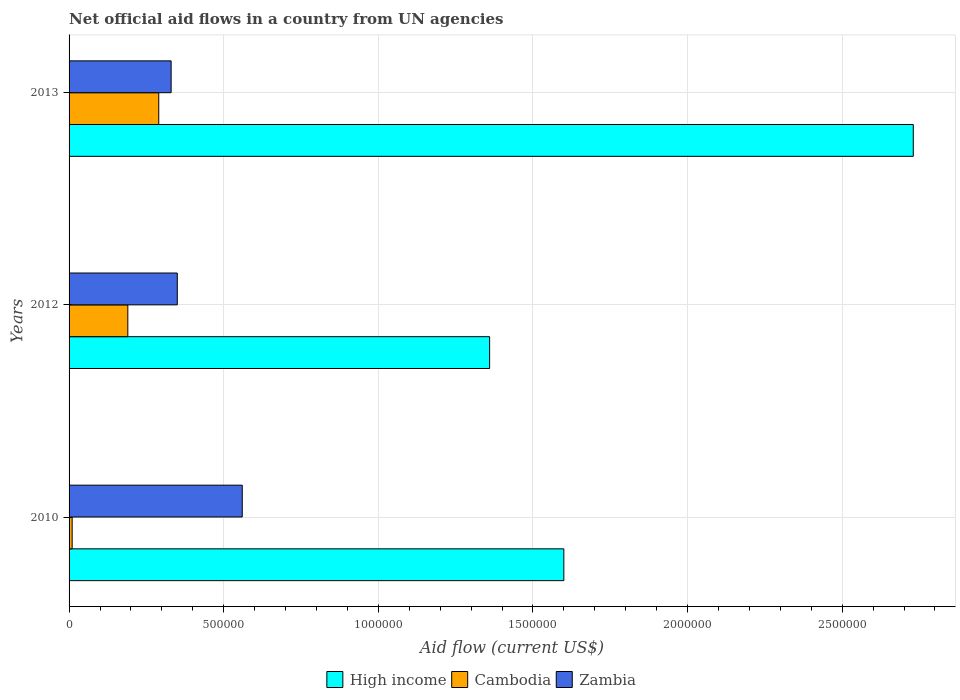How many different coloured bars are there?
Give a very brief answer. 3. How many groups of bars are there?
Offer a terse response. 3. Are the number of bars per tick equal to the number of legend labels?
Your answer should be compact. Yes. Are the number of bars on each tick of the Y-axis equal?
Provide a short and direct response. Yes. How many bars are there on the 1st tick from the top?
Make the answer very short. 3. What is the label of the 2nd group of bars from the top?
Ensure brevity in your answer.  2012. In how many cases, is the number of bars for a given year not equal to the number of legend labels?
Offer a terse response. 0. What is the net official aid flow in High income in 2010?
Your answer should be very brief. 1.60e+06. Across all years, what is the maximum net official aid flow in High income?
Ensure brevity in your answer.  2.73e+06. Across all years, what is the minimum net official aid flow in High income?
Provide a succinct answer. 1.36e+06. In which year was the net official aid flow in Zambia maximum?
Your response must be concise. 2010. What is the total net official aid flow in High income in the graph?
Provide a short and direct response. 5.69e+06. What is the difference between the net official aid flow in Cambodia in 2010 and that in 2013?
Keep it short and to the point. -2.80e+05. What is the difference between the net official aid flow in Cambodia in 2013 and the net official aid flow in High income in 2012?
Keep it short and to the point. -1.07e+06. What is the average net official aid flow in High income per year?
Your answer should be very brief. 1.90e+06. In how many years, is the net official aid flow in High income greater than 2300000 US$?
Your response must be concise. 1. What is the ratio of the net official aid flow in Cambodia in 2010 to that in 2013?
Give a very brief answer. 0.03. Is the net official aid flow in High income in 2012 less than that in 2013?
Ensure brevity in your answer.  Yes. Is the difference between the net official aid flow in Zambia in 2010 and 2013 greater than the difference between the net official aid flow in Cambodia in 2010 and 2013?
Give a very brief answer. Yes. What is the difference between the highest and the second highest net official aid flow in High income?
Keep it short and to the point. 1.13e+06. What is the difference between the highest and the lowest net official aid flow in Cambodia?
Offer a very short reply. 2.80e+05. In how many years, is the net official aid flow in Zambia greater than the average net official aid flow in Zambia taken over all years?
Give a very brief answer. 1. Is the sum of the net official aid flow in High income in 2010 and 2013 greater than the maximum net official aid flow in Cambodia across all years?
Ensure brevity in your answer.  Yes. What does the 2nd bar from the top in 2012 represents?
Your answer should be very brief. Cambodia. What does the 2nd bar from the bottom in 2010 represents?
Offer a very short reply. Cambodia. Is it the case that in every year, the sum of the net official aid flow in Zambia and net official aid flow in Cambodia is greater than the net official aid flow in High income?
Your response must be concise. No. How many years are there in the graph?
Make the answer very short. 3. Does the graph contain any zero values?
Your answer should be very brief. No. What is the title of the graph?
Your answer should be compact. Net official aid flows in a country from UN agencies. Does "Austria" appear as one of the legend labels in the graph?
Give a very brief answer. No. What is the label or title of the X-axis?
Ensure brevity in your answer.  Aid flow (current US$). What is the Aid flow (current US$) in High income in 2010?
Your answer should be very brief. 1.60e+06. What is the Aid flow (current US$) of Zambia in 2010?
Offer a very short reply. 5.60e+05. What is the Aid flow (current US$) of High income in 2012?
Offer a very short reply. 1.36e+06. What is the Aid flow (current US$) in Cambodia in 2012?
Your answer should be very brief. 1.90e+05. What is the Aid flow (current US$) of Zambia in 2012?
Keep it short and to the point. 3.50e+05. What is the Aid flow (current US$) in High income in 2013?
Your response must be concise. 2.73e+06. Across all years, what is the maximum Aid flow (current US$) of High income?
Provide a succinct answer. 2.73e+06. Across all years, what is the maximum Aid flow (current US$) of Zambia?
Provide a succinct answer. 5.60e+05. Across all years, what is the minimum Aid flow (current US$) of High income?
Keep it short and to the point. 1.36e+06. Across all years, what is the minimum Aid flow (current US$) in Zambia?
Make the answer very short. 3.30e+05. What is the total Aid flow (current US$) in High income in the graph?
Offer a very short reply. 5.69e+06. What is the total Aid flow (current US$) in Zambia in the graph?
Offer a very short reply. 1.24e+06. What is the difference between the Aid flow (current US$) of High income in 2010 and that in 2013?
Your response must be concise. -1.13e+06. What is the difference between the Aid flow (current US$) of Cambodia in 2010 and that in 2013?
Ensure brevity in your answer.  -2.80e+05. What is the difference between the Aid flow (current US$) in High income in 2012 and that in 2013?
Your response must be concise. -1.37e+06. What is the difference between the Aid flow (current US$) of High income in 2010 and the Aid flow (current US$) of Cambodia in 2012?
Your answer should be compact. 1.41e+06. What is the difference between the Aid flow (current US$) of High income in 2010 and the Aid flow (current US$) of Zambia in 2012?
Make the answer very short. 1.25e+06. What is the difference between the Aid flow (current US$) of High income in 2010 and the Aid flow (current US$) of Cambodia in 2013?
Your response must be concise. 1.31e+06. What is the difference between the Aid flow (current US$) in High income in 2010 and the Aid flow (current US$) in Zambia in 2013?
Provide a succinct answer. 1.27e+06. What is the difference between the Aid flow (current US$) in Cambodia in 2010 and the Aid flow (current US$) in Zambia in 2013?
Ensure brevity in your answer.  -3.20e+05. What is the difference between the Aid flow (current US$) of High income in 2012 and the Aid flow (current US$) of Cambodia in 2013?
Your answer should be very brief. 1.07e+06. What is the difference between the Aid flow (current US$) in High income in 2012 and the Aid flow (current US$) in Zambia in 2013?
Keep it short and to the point. 1.03e+06. What is the average Aid flow (current US$) of High income per year?
Offer a terse response. 1.90e+06. What is the average Aid flow (current US$) in Cambodia per year?
Offer a terse response. 1.63e+05. What is the average Aid flow (current US$) of Zambia per year?
Make the answer very short. 4.13e+05. In the year 2010, what is the difference between the Aid flow (current US$) in High income and Aid flow (current US$) in Cambodia?
Make the answer very short. 1.59e+06. In the year 2010, what is the difference between the Aid flow (current US$) in High income and Aid flow (current US$) in Zambia?
Provide a short and direct response. 1.04e+06. In the year 2010, what is the difference between the Aid flow (current US$) in Cambodia and Aid flow (current US$) in Zambia?
Make the answer very short. -5.50e+05. In the year 2012, what is the difference between the Aid flow (current US$) of High income and Aid flow (current US$) of Cambodia?
Your answer should be very brief. 1.17e+06. In the year 2012, what is the difference between the Aid flow (current US$) of High income and Aid flow (current US$) of Zambia?
Keep it short and to the point. 1.01e+06. In the year 2012, what is the difference between the Aid flow (current US$) of Cambodia and Aid flow (current US$) of Zambia?
Make the answer very short. -1.60e+05. In the year 2013, what is the difference between the Aid flow (current US$) in High income and Aid flow (current US$) in Cambodia?
Offer a very short reply. 2.44e+06. In the year 2013, what is the difference between the Aid flow (current US$) of High income and Aid flow (current US$) of Zambia?
Provide a succinct answer. 2.40e+06. In the year 2013, what is the difference between the Aid flow (current US$) in Cambodia and Aid flow (current US$) in Zambia?
Offer a very short reply. -4.00e+04. What is the ratio of the Aid flow (current US$) of High income in 2010 to that in 2012?
Provide a short and direct response. 1.18. What is the ratio of the Aid flow (current US$) of Cambodia in 2010 to that in 2012?
Make the answer very short. 0.05. What is the ratio of the Aid flow (current US$) in High income in 2010 to that in 2013?
Keep it short and to the point. 0.59. What is the ratio of the Aid flow (current US$) of Cambodia in 2010 to that in 2013?
Provide a succinct answer. 0.03. What is the ratio of the Aid flow (current US$) of Zambia in 2010 to that in 2013?
Offer a terse response. 1.7. What is the ratio of the Aid flow (current US$) in High income in 2012 to that in 2013?
Your answer should be very brief. 0.5. What is the ratio of the Aid flow (current US$) of Cambodia in 2012 to that in 2013?
Make the answer very short. 0.66. What is the ratio of the Aid flow (current US$) in Zambia in 2012 to that in 2013?
Make the answer very short. 1.06. What is the difference between the highest and the second highest Aid flow (current US$) of High income?
Offer a terse response. 1.13e+06. What is the difference between the highest and the lowest Aid flow (current US$) of High income?
Make the answer very short. 1.37e+06. What is the difference between the highest and the lowest Aid flow (current US$) of Cambodia?
Ensure brevity in your answer.  2.80e+05. 